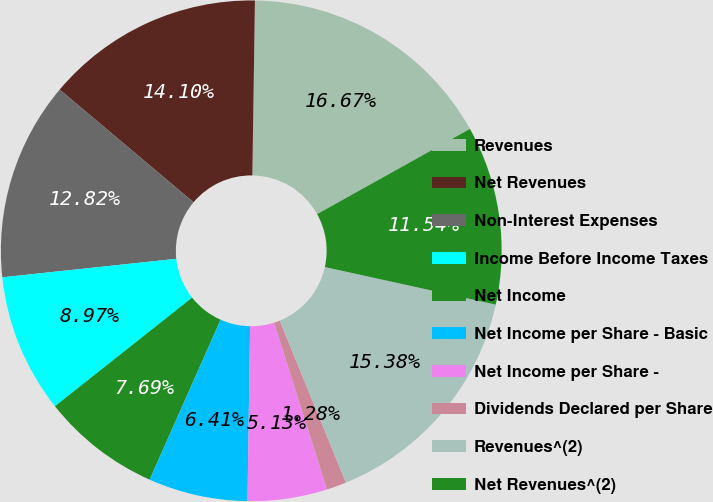Convert chart. <chart><loc_0><loc_0><loc_500><loc_500><pie_chart><fcel>Revenues<fcel>Net Revenues<fcel>Non-Interest Expenses<fcel>Income Before Income Taxes<fcel>Net Income<fcel>Net Income per Share - Basic<fcel>Net Income per Share -<fcel>Dividends Declared per Share<fcel>Revenues^(2)<fcel>Net Revenues^(2)<nl><fcel>16.67%<fcel>14.1%<fcel>12.82%<fcel>8.97%<fcel>7.69%<fcel>6.41%<fcel>5.13%<fcel>1.28%<fcel>15.38%<fcel>11.54%<nl></chart> 